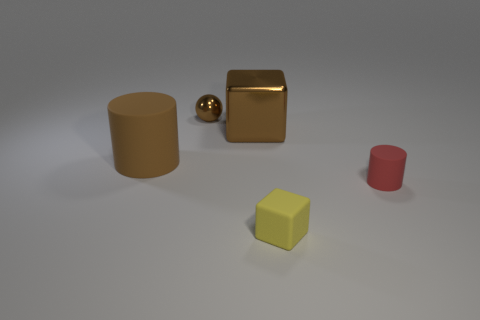There is a yellow object; is it the same shape as the matte thing on the left side of the tiny yellow object?
Provide a succinct answer. No. There is a tiny object that is the same shape as the big brown metal object; what material is it?
Keep it short and to the point. Rubber. What number of tiny objects are either brown spheres or metallic cubes?
Your answer should be compact. 1. Is the number of metallic objects in front of the metal ball less than the number of big brown objects on the left side of the small red object?
Keep it short and to the point. Yes. How many objects are matte things or small red rubber cylinders?
Give a very brief answer. 3. There is a tiny red rubber thing; what number of red rubber things are behind it?
Provide a short and direct response. 0. Is the big cylinder the same color as the small metallic object?
Ensure brevity in your answer.  Yes. What shape is the brown object that is made of the same material as the brown block?
Your answer should be compact. Sphere. There is a small object on the right side of the matte cube; is it the same shape as the tiny brown metal object?
Ensure brevity in your answer.  No. What number of brown things are small cylinders or tiny metal spheres?
Give a very brief answer. 1. 